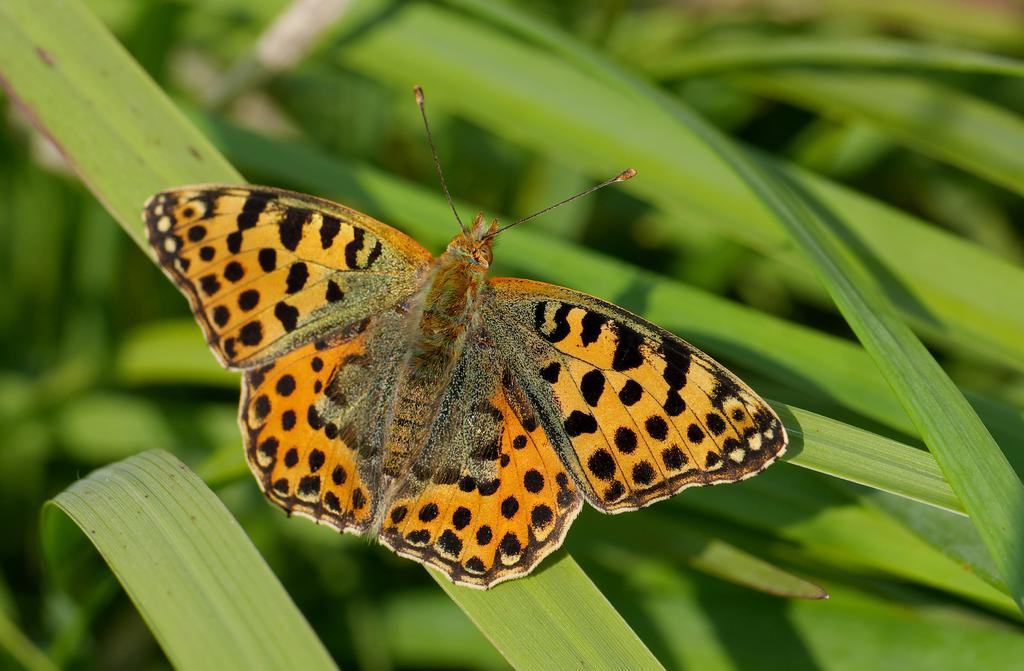What is the main subject of the image? There is a butterfly in the image. Where is the butterfly located? The butterfly is on a leaf. Can you describe the background of the image? The background of the image is blurred. What else can be seen in the image besides the butterfly? There are leaves visible in the image. How many feet does the butterfly have in the image? Butterflies do not have feet; they have six legs. However, in the image, the legs are not visible, so we cannot determine the number of feet or legs. 